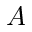<formula> <loc_0><loc_0><loc_500><loc_500>A</formula> 